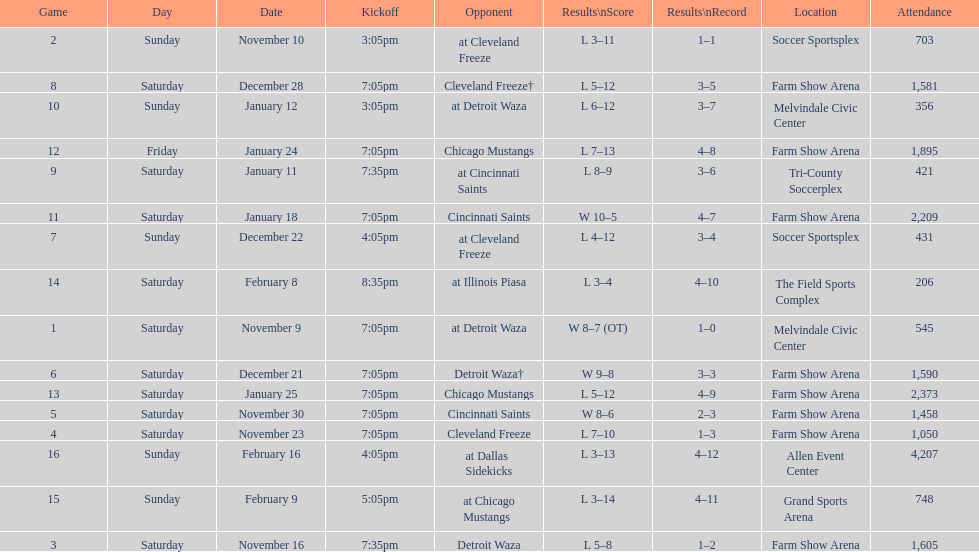What is the date of the game after december 22? December 28. 